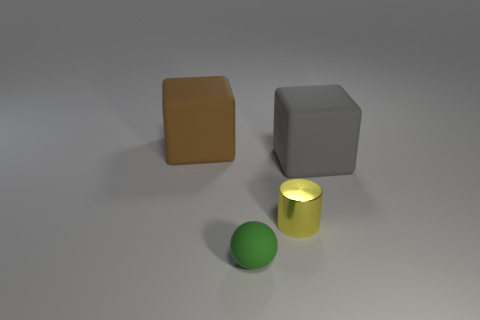Is there any other thing that has the same shape as the yellow thing?
Offer a terse response. No. How many shiny things are either gray blocks or big green blocks?
Offer a terse response. 0. The big matte thing to the left of the large rubber cube to the right of the green rubber sphere is what shape?
Offer a terse response. Cube. Do the large object that is behind the gray block and the tiny yellow thing that is in front of the big brown rubber cube have the same material?
Your response must be concise. No. There is a big object that is to the right of the tiny yellow metal thing; what number of large brown cubes are on the right side of it?
Give a very brief answer. 0. There is a large object that is to the right of the large brown block; is its shape the same as the small object that is on the left side of the small metallic thing?
Your answer should be very brief. No. There is a thing that is to the left of the small shiny object and behind the green sphere; how big is it?
Your response must be concise. Large. There is another thing that is the same shape as the large brown thing; what is its color?
Give a very brief answer. Gray. There is a large rubber block that is on the left side of the matte cube right of the tiny matte ball; what color is it?
Your answer should be compact. Brown. There is a brown object; what shape is it?
Offer a very short reply. Cube. 